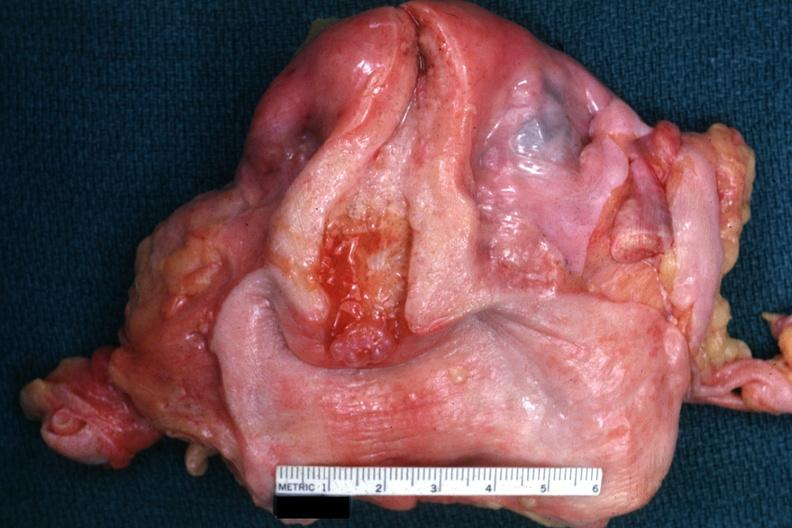s lesion in dome of uterus present?
Answer the question using a single word or phrase. No 